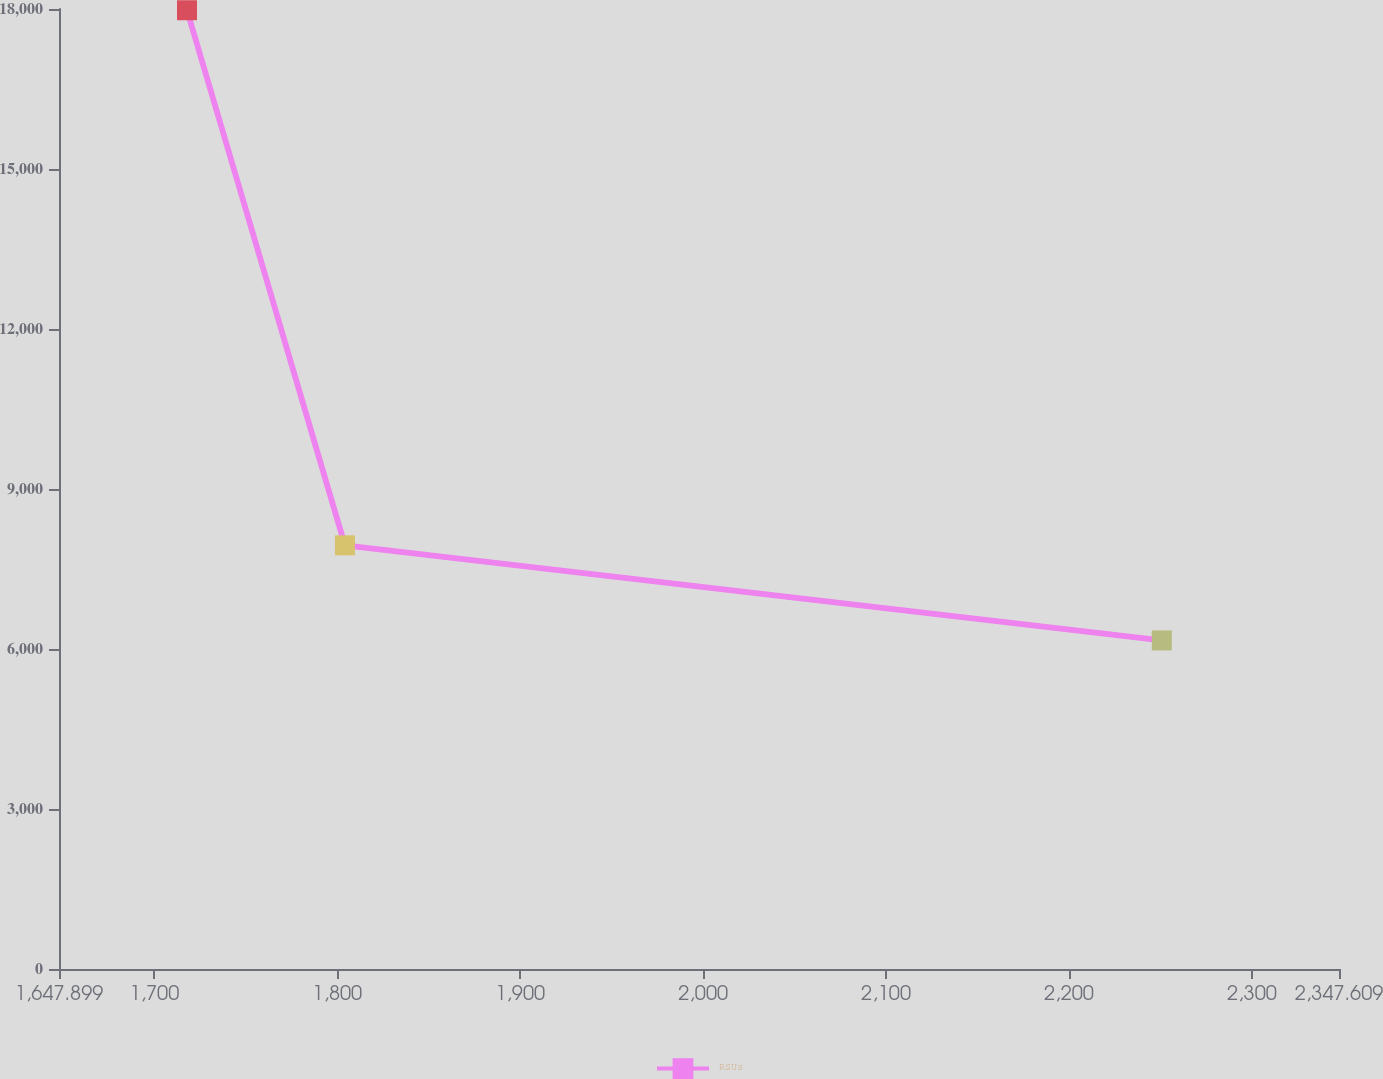<chart> <loc_0><loc_0><loc_500><loc_500><line_chart><ecel><fcel>RSUs<nl><fcel>1717.87<fcel>17976.7<nl><fcel>1804.21<fcel>7943.1<nl><fcel>2250.74<fcel>6160.28<nl><fcel>2349.96<fcel>3073.15<nl><fcel>2417.58<fcel>148.49<nl></chart> 